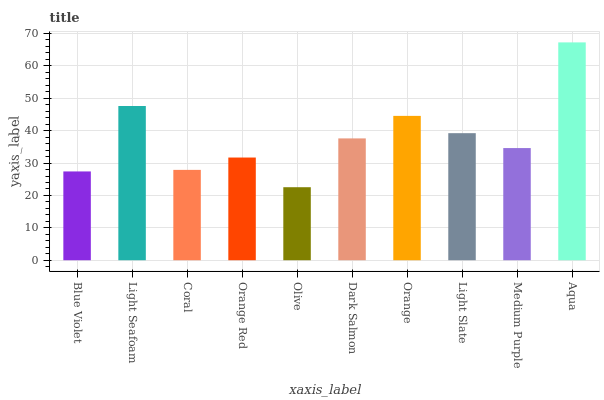Is Olive the minimum?
Answer yes or no. Yes. Is Aqua the maximum?
Answer yes or no. Yes. Is Light Seafoam the minimum?
Answer yes or no. No. Is Light Seafoam the maximum?
Answer yes or no. No. Is Light Seafoam greater than Blue Violet?
Answer yes or no. Yes. Is Blue Violet less than Light Seafoam?
Answer yes or no. Yes. Is Blue Violet greater than Light Seafoam?
Answer yes or no. No. Is Light Seafoam less than Blue Violet?
Answer yes or no. No. Is Dark Salmon the high median?
Answer yes or no. Yes. Is Medium Purple the low median?
Answer yes or no. Yes. Is Orange Red the high median?
Answer yes or no. No. Is Orange the low median?
Answer yes or no. No. 